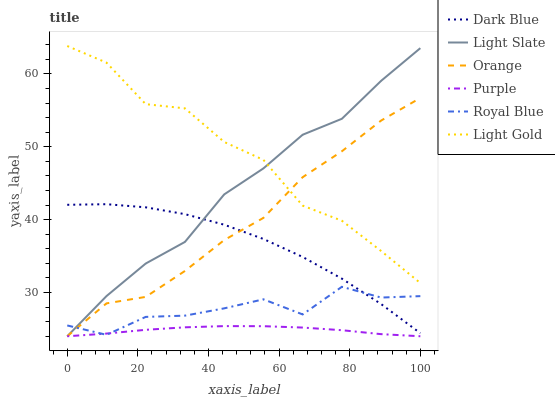Does Royal Blue have the minimum area under the curve?
Answer yes or no. No. Does Royal Blue have the maximum area under the curve?
Answer yes or no. No. Is Royal Blue the smoothest?
Answer yes or no. No. Is Royal Blue the roughest?
Answer yes or no. No. Does Royal Blue have the lowest value?
Answer yes or no. No. Does Royal Blue have the highest value?
Answer yes or no. No. Is Purple less than Light Gold?
Answer yes or no. Yes. Is Dark Blue greater than Purple?
Answer yes or no. Yes. Does Purple intersect Light Gold?
Answer yes or no. No. 